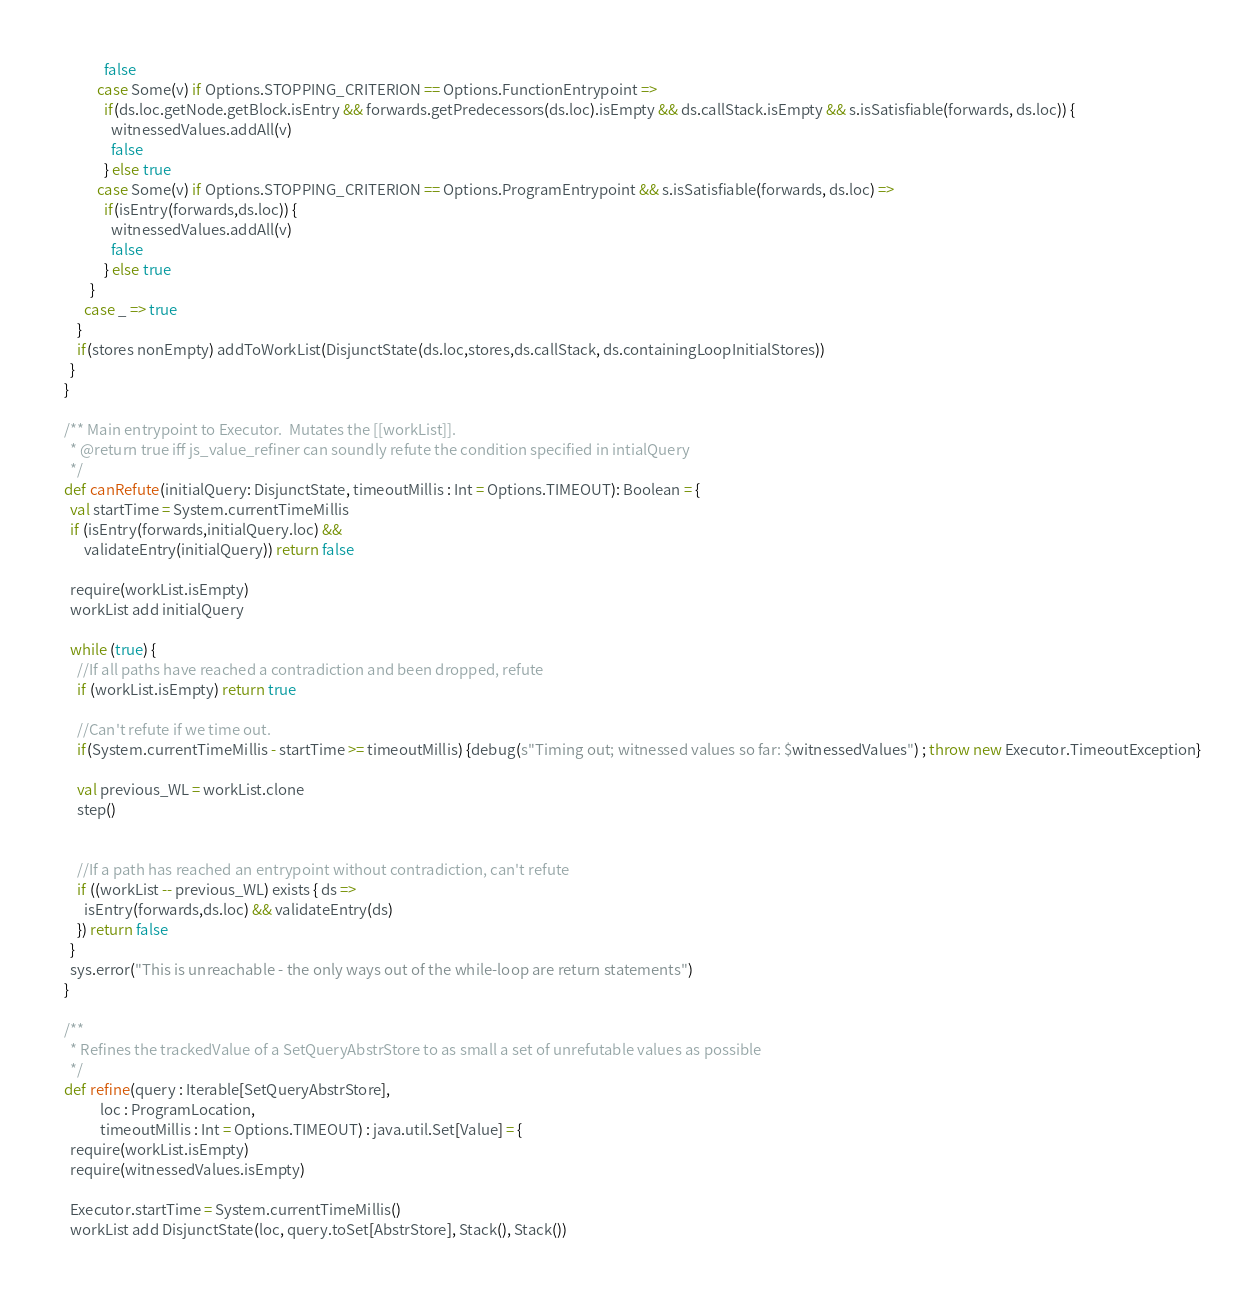Convert code to text. <code><loc_0><loc_0><loc_500><loc_500><_Scala_>              false
            case Some(v) if Options.STOPPING_CRITERION == Options.FunctionEntrypoint =>
              if(ds.loc.getNode.getBlock.isEntry && forwards.getPredecessors(ds.loc).isEmpty && ds.callStack.isEmpty && s.isSatisfiable(forwards, ds.loc)) {
                witnessedValues.addAll(v)
                false
              } else true
            case Some(v) if Options.STOPPING_CRITERION == Options.ProgramEntrypoint && s.isSatisfiable(forwards, ds.loc) =>
              if(isEntry(forwards,ds.loc)) {
                witnessedValues.addAll(v)
                false
              } else true
          }
        case _ => true
      }
      if(stores nonEmpty) addToWorkList(DisjunctState(ds.loc,stores,ds.callStack, ds.containingLoopInitialStores))
    }
  }

  /** Main entrypoint to Executor.  Mutates the [[workList]].
    * @return true iff js_value_refiner can soundly refute the condition specified in intialQuery
    */
  def canRefute(initialQuery: DisjunctState, timeoutMillis : Int = Options.TIMEOUT): Boolean = {
    val startTime = System.currentTimeMillis
    if (isEntry(forwards,initialQuery.loc) &&
        validateEntry(initialQuery)) return false

    require(workList.isEmpty)
    workList add initialQuery

    while (true) {
      //If all paths have reached a contradiction and been dropped, refute
      if (workList.isEmpty) return true

      //Can't refute if we time out.
      if(System.currentTimeMillis - startTime >= timeoutMillis) {debug(s"Timing out; witnessed values so far: $witnessedValues") ; throw new Executor.TimeoutException}

      val previous_WL = workList.clone
      step()


      //If a path has reached an entrypoint without contradiction, can't refute
      if ((workList -- previous_WL) exists { ds =>
        isEntry(forwards,ds.loc) && validateEntry(ds)
      }) return false
    }
    sys.error("This is unreachable - the only ways out of the while-loop are return statements")
  }

  /**
    * Refines the trackedValue of a SetQueryAbstrStore to as small a set of unrefutable values as possible
    */
  def refine(query : Iterable[SetQueryAbstrStore],
             loc : ProgramLocation,
             timeoutMillis : Int = Options.TIMEOUT) : java.util.Set[Value] = {
    require(workList.isEmpty)
    require(witnessedValues.isEmpty)

    Executor.startTime = System.currentTimeMillis()
    workList add DisjunctState(loc, query.toSet[AbstrStore], Stack(), Stack())
</code> 